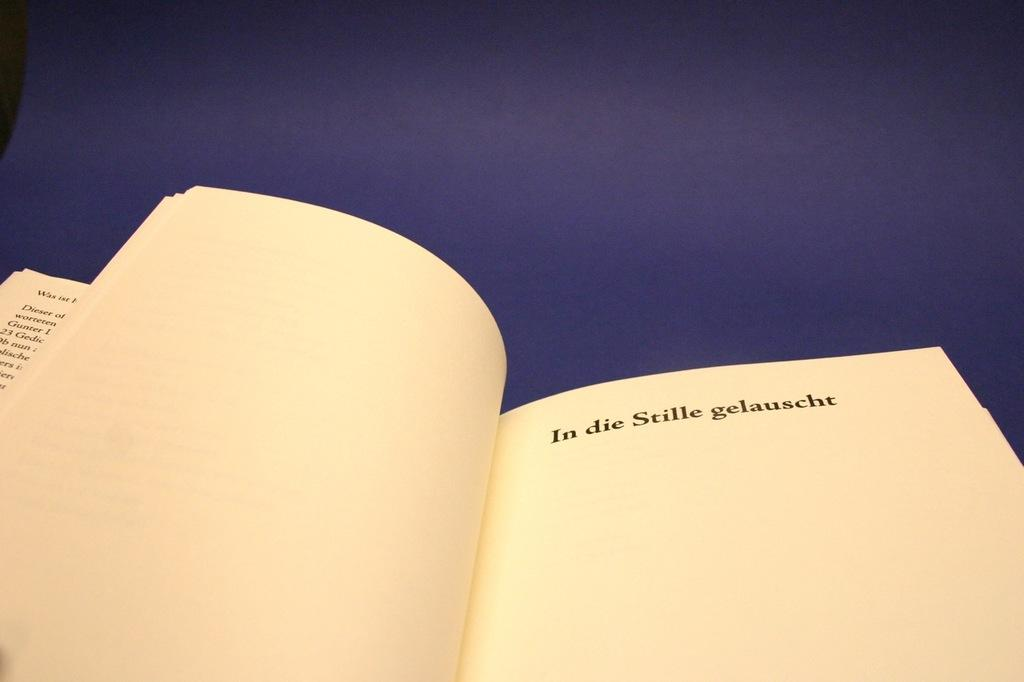<image>
Create a compact narrative representing the image presented. A page in a book that begins with "In die Stille gelauscht." 